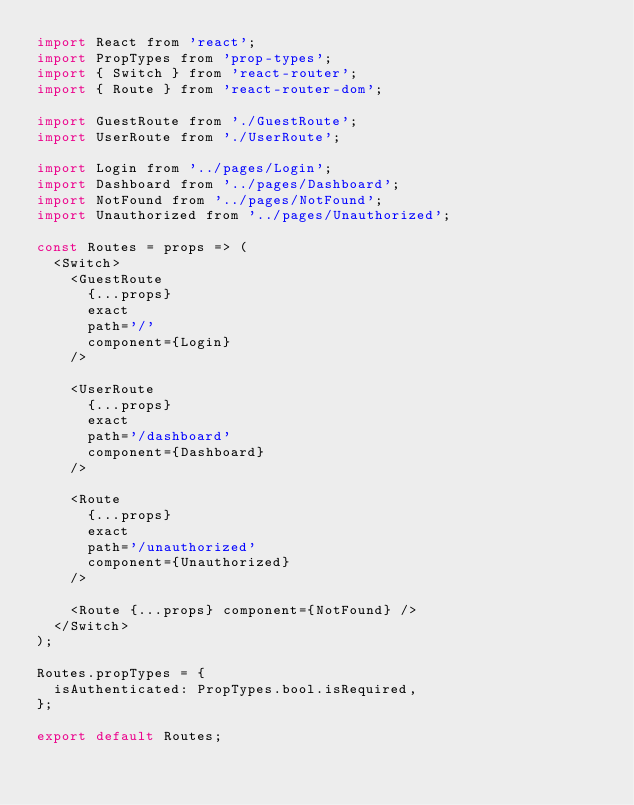Convert code to text. <code><loc_0><loc_0><loc_500><loc_500><_JavaScript_>import React from 'react';
import PropTypes from 'prop-types';
import { Switch } from 'react-router';
import { Route } from 'react-router-dom';

import GuestRoute from './GuestRoute';
import UserRoute from './UserRoute';

import Login from '../pages/Login';
import Dashboard from '../pages/Dashboard';
import NotFound from '../pages/NotFound';
import Unauthorized from '../pages/Unauthorized';

const Routes = props => (
  <Switch>
    <GuestRoute
      {...props}
      exact
      path='/'
      component={Login}
    />

    <UserRoute
      {...props}
      exact
      path='/dashboard'
      component={Dashboard}
    />

    <Route
      {...props}
      exact
      path='/unauthorized'
      component={Unauthorized}
    />

    <Route {...props} component={NotFound} />
  </Switch>
);

Routes.propTypes = {
  isAuthenticated: PropTypes.bool.isRequired,
};

export default Routes;
</code> 